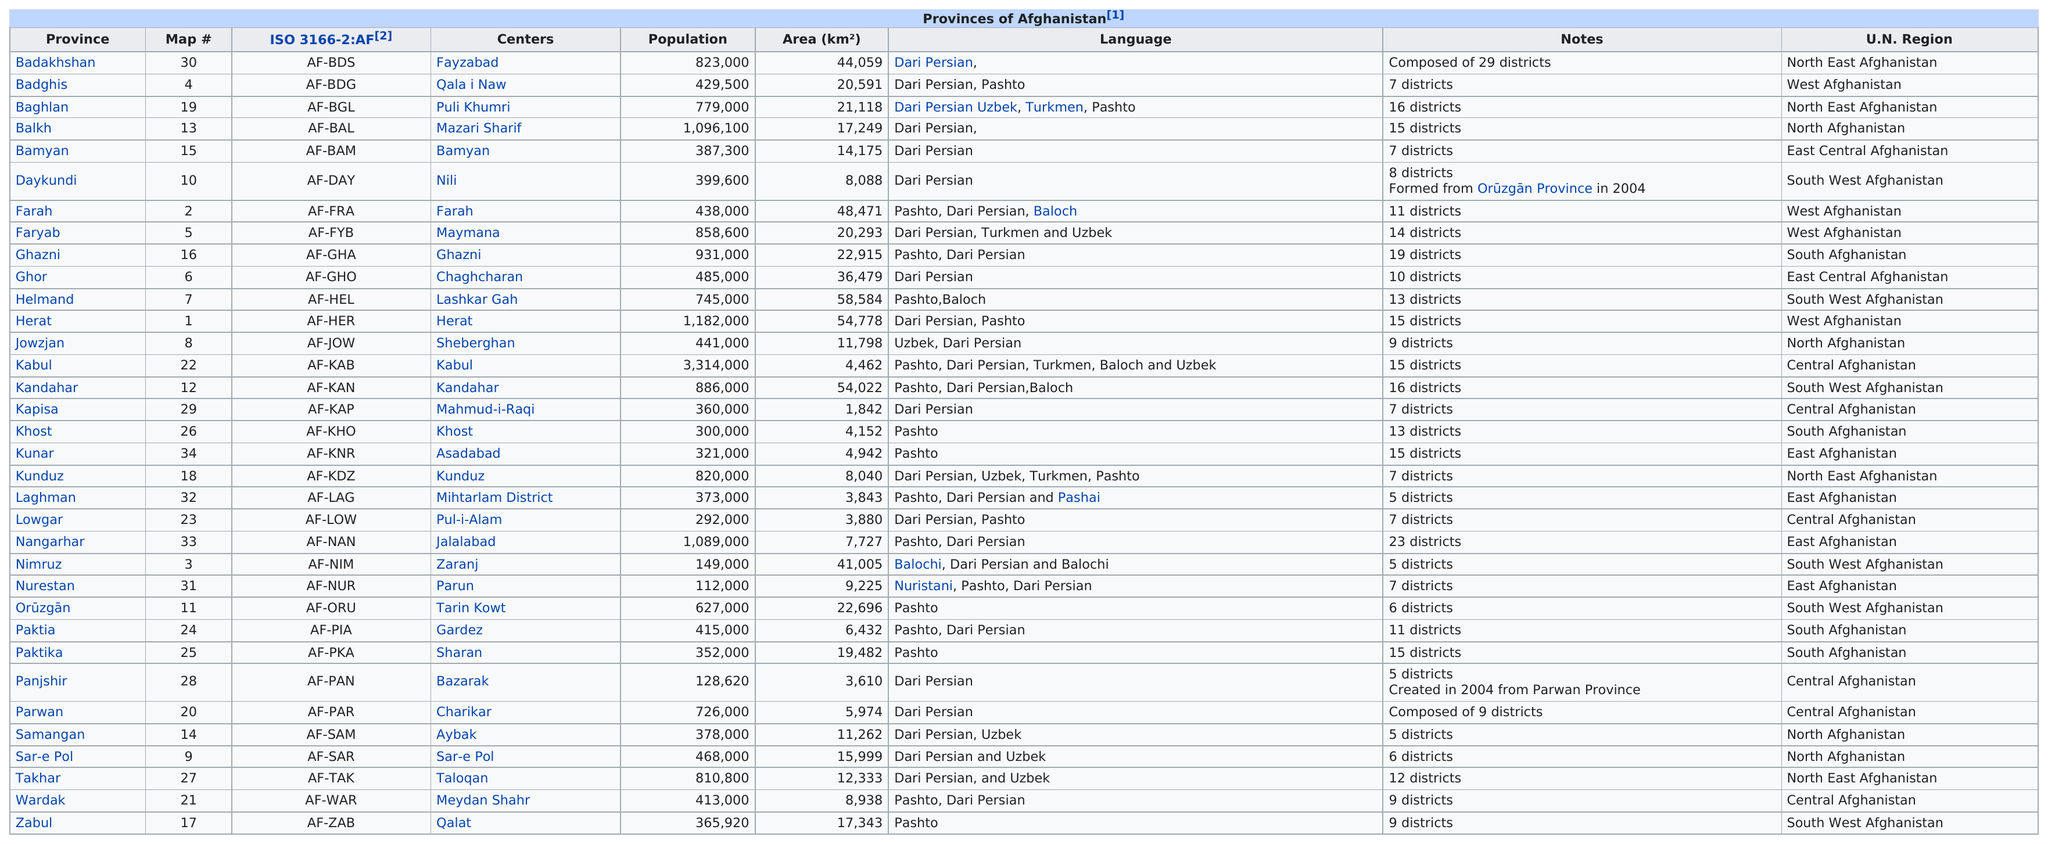Identify some key points in this picture. Nurestan has the least population among all the provinces. There are 28 provinces in Afghanistan that primarily speak Dari, a variant of Persian. There are 7 districts in the province of Kunduz. I am not sure what you are asking. Could you please provide more context or clarify your question? Ghazni is located in the previous province to Ghor. 